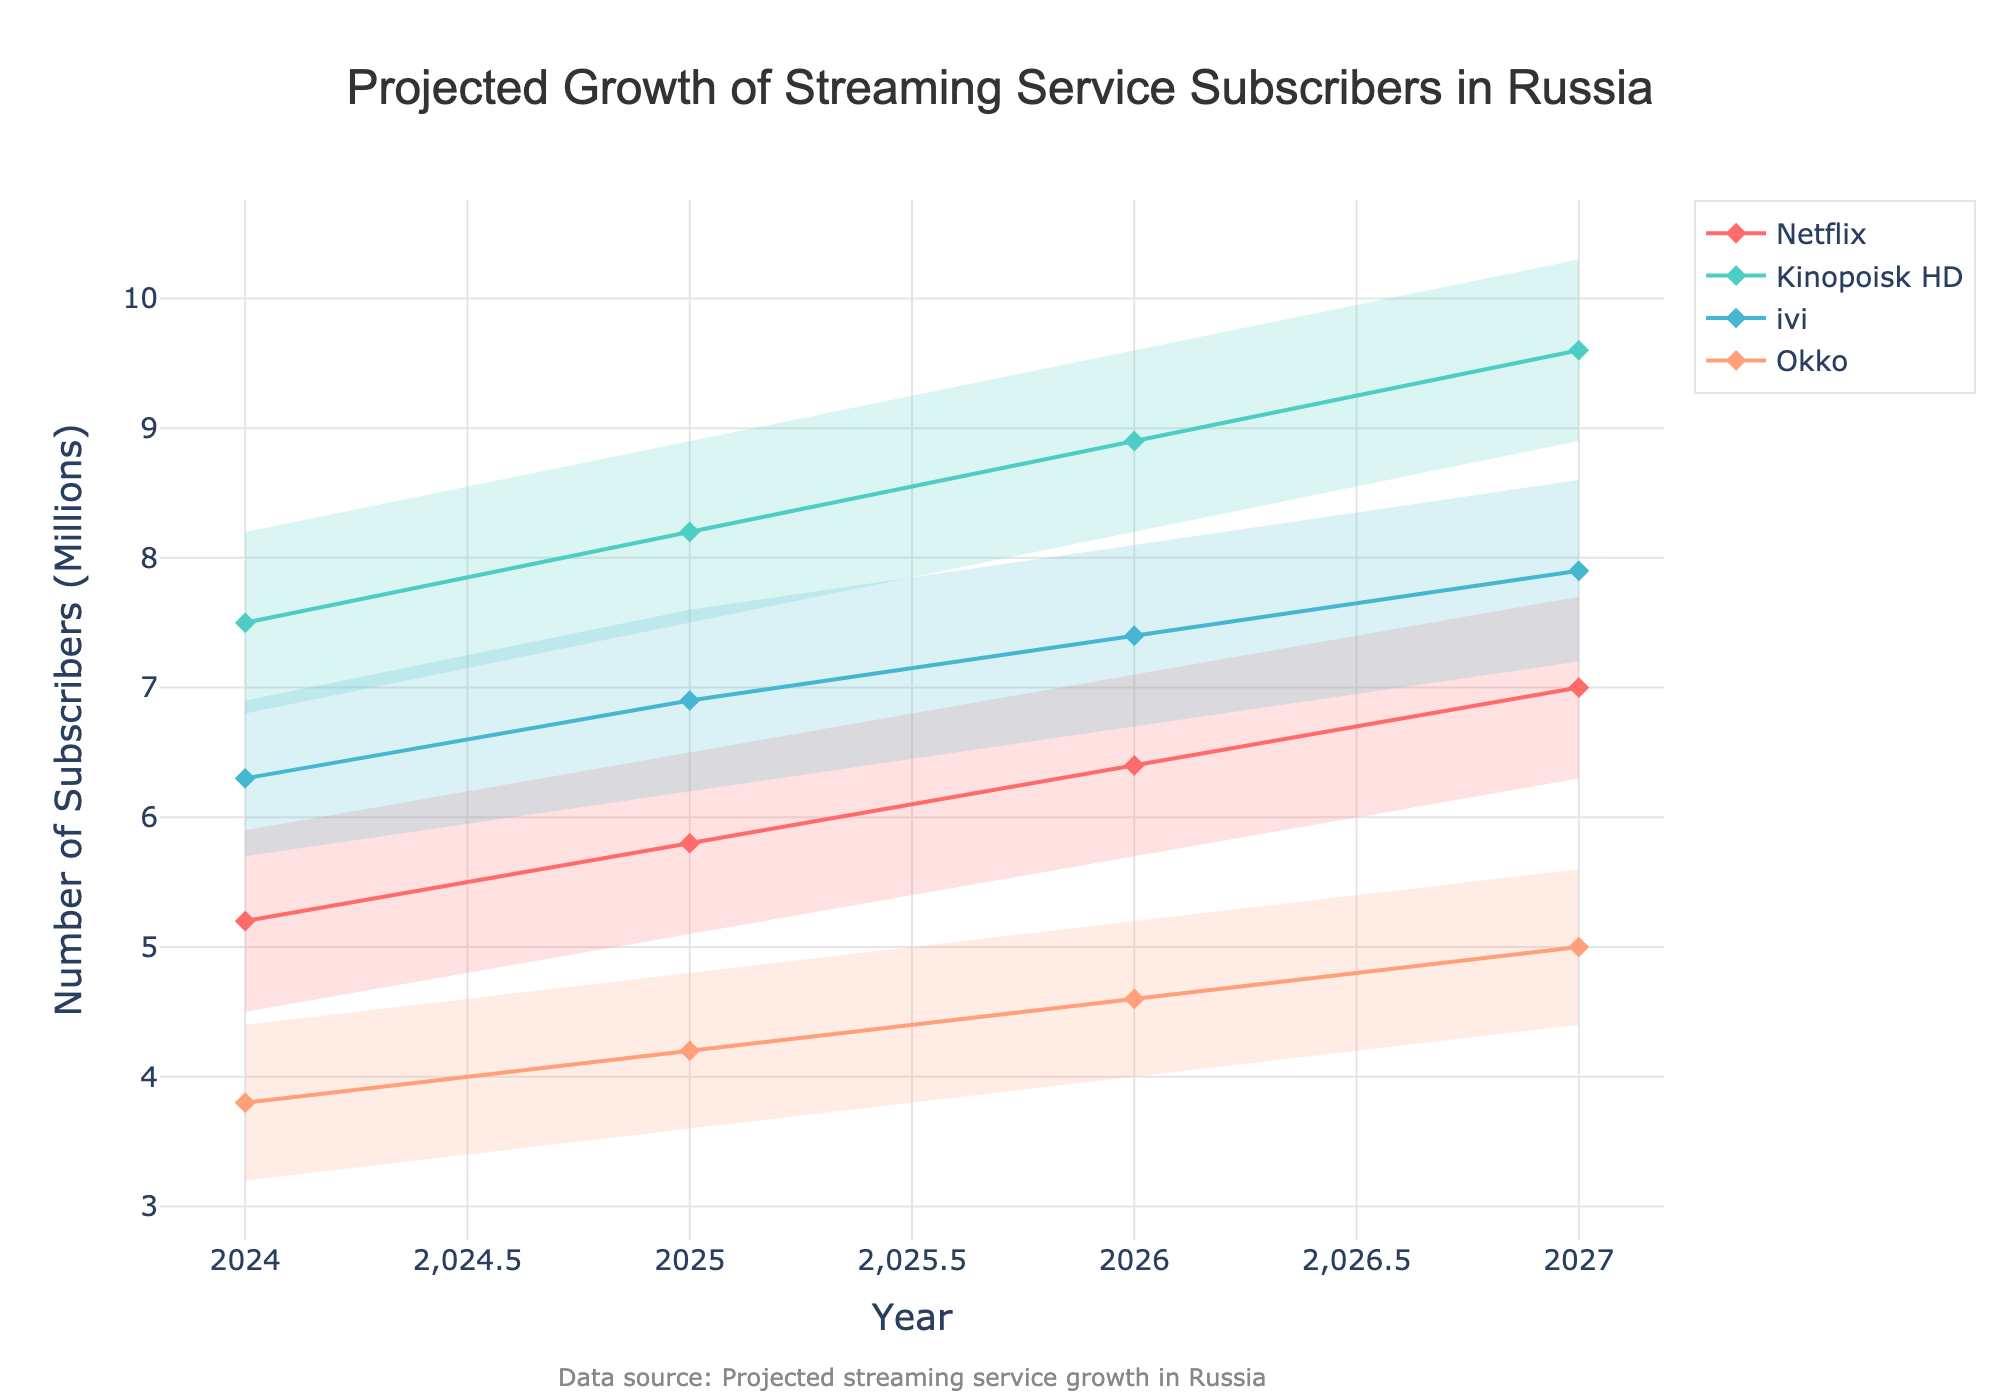What's the projected median number of Netflix subscribers in 2026? Refer to the median line for Netflix in 2026 and note the value at the intersection with the year 2026.
Answer: 6.4 million Which streaming platform has the highest projected median number of subscribers in 2027? Compare the projected median subscriber values for all platforms in 2027; the highest value would be the maximum among them.
Answer: Kinopoisk HD How does the median number of ivi subscribers change from 2024 to 2025? Check the median values for ivi in 2024 and 2025, then calculate the difference (2025 median - 2024 median).
Answer: 0.6 million increase What is the median projected subscriber growth for Okko from 2026 to 2027? Refer to the median values for Okko in 2026 and 2027, then find the difference (2027 median - 2026 median).
Answer: 0.4 million increase By how many subscribers does Kinopoisk HD's highest projection in 2026 exceed Netflix's highest projection in 2026? Look at the highest projection values for both platforms in 2026 and find the difference (Kinopoisk HD's high - Netflix's high).
Answer: 2.5 million Which platform is projected to have the lowest number of subscribers in 2024 according to its low projection? Compare the low value projections for all platforms in 2024 and find the smallest one.
Answer: Okko What's the average projected median number of subscribers for Netflix over the years 2024 to 2027? Sum the median values for Netflix from 2024 to 2027 and divide by the number of years (4).
Answer: 6.1 million In which year is the gap between the high and low projections for ivi the smallest? For each year, calculate the difference between ivi's high and low projections, then identify the year with the smallest difference.
Answer: 2024 What's the overall trend for Kinopoisk HD's median number of subscribers from 2024 to 2027? Observe the trend in the median values for Kinopoisk HD from 2024 to 2027.
Answer: Increasing trend Compare the median subscriber projection of Okko in 2026 with the low projection of Netflix in the same year. Find the median value for Okko in 2026 and compare it with the low value for Netflix in 2026.
Answer: Okko's median is higher 